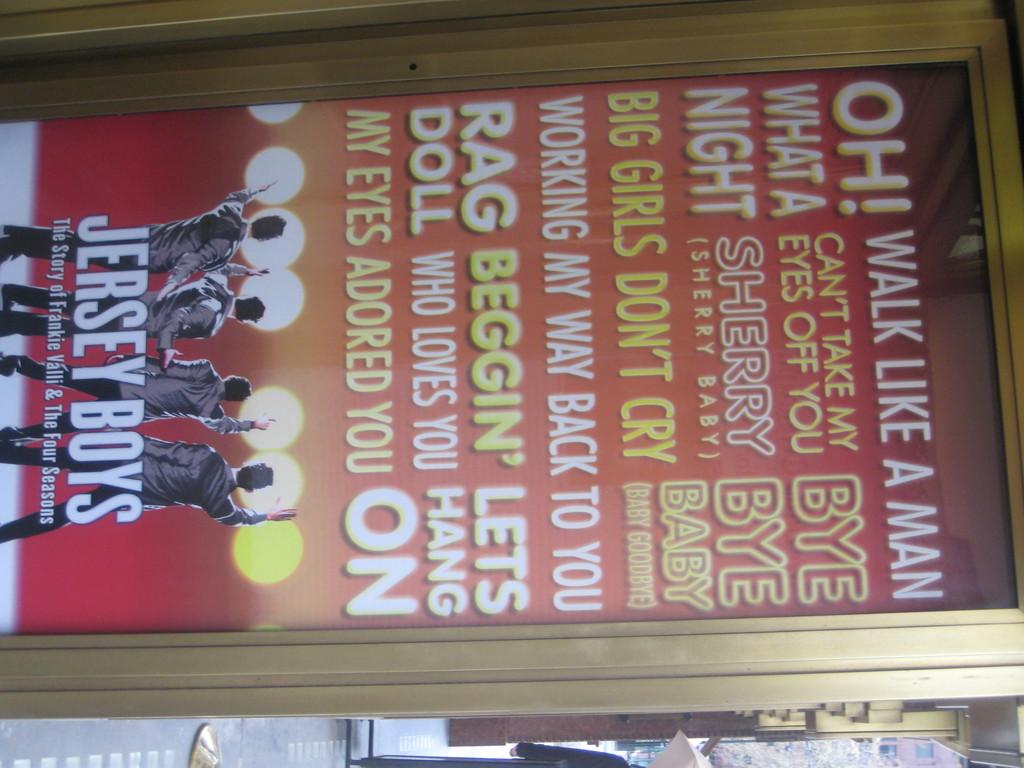What is present in the image that contains text? The image contains a poster with words on it. How many people are depicted on the poster? There are four people depicted on the poster. What can be seen in the background of the image? There is a tree and a building in the background of the image. What type of bridge can be seen connecting the two buildings in the image? There is no bridge present in the image; it only features a poster with people on it and a tree and building in the background. 